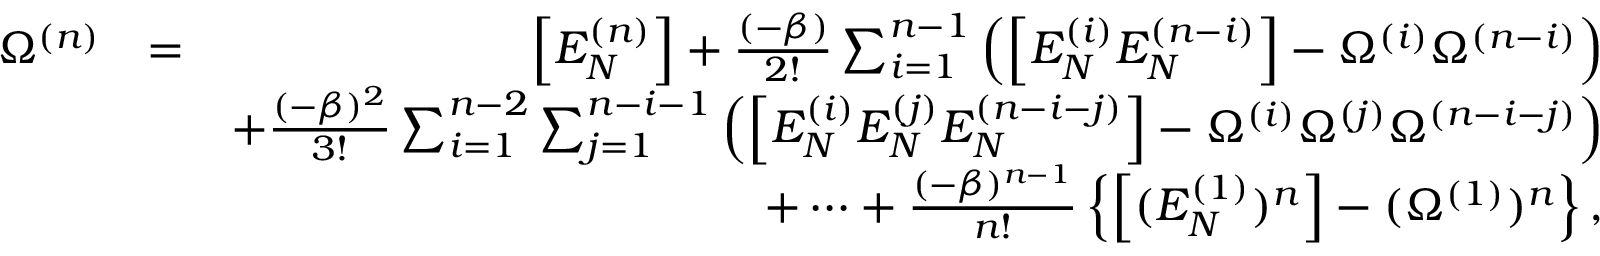Convert formula to latex. <formula><loc_0><loc_0><loc_500><loc_500>\begin{array} { r l r } { \Omega ^ { ( n ) } } & { = } & { \left [ E _ { N } ^ { ( n ) } \right ] + \frac { ( - \beta ) } { 2 ! } \sum _ { i = 1 } ^ { n - 1 } \left ( \left [ E _ { N } ^ { ( i ) } E _ { N } ^ { ( n - i ) } \right ] - \Omega ^ { ( i ) } \Omega ^ { ( n - i ) } \right ) } \\ & { + \frac { ( - \beta ) ^ { 2 } } { 3 ! } \sum _ { i = 1 } ^ { n - 2 } \sum _ { j = 1 } ^ { n - i - 1 } \left ( \left [ E _ { N } ^ { ( i ) } E _ { N } ^ { ( j ) } E _ { N } ^ { ( n - i - j ) } \right ] - \Omega ^ { ( i ) } \Omega ^ { ( j ) } \Omega ^ { ( n - i - j ) } \right ) } \\ & { + \cdots + \frac { ( - \beta ) ^ { n - 1 } } { n ! } \left \{ \left [ ( E _ { N } ^ { ( 1 ) } ) ^ { n } \right ] - ( \Omega ^ { ( 1 ) } ) ^ { n } \right \} , } \end{array}</formula> 